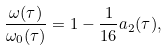<formula> <loc_0><loc_0><loc_500><loc_500>\frac { \omega ( \tau ) } { \omega _ { 0 } ( \tau ) } = 1 - \frac { 1 } { 1 6 } a _ { 2 } ( \tau ) ,</formula> 